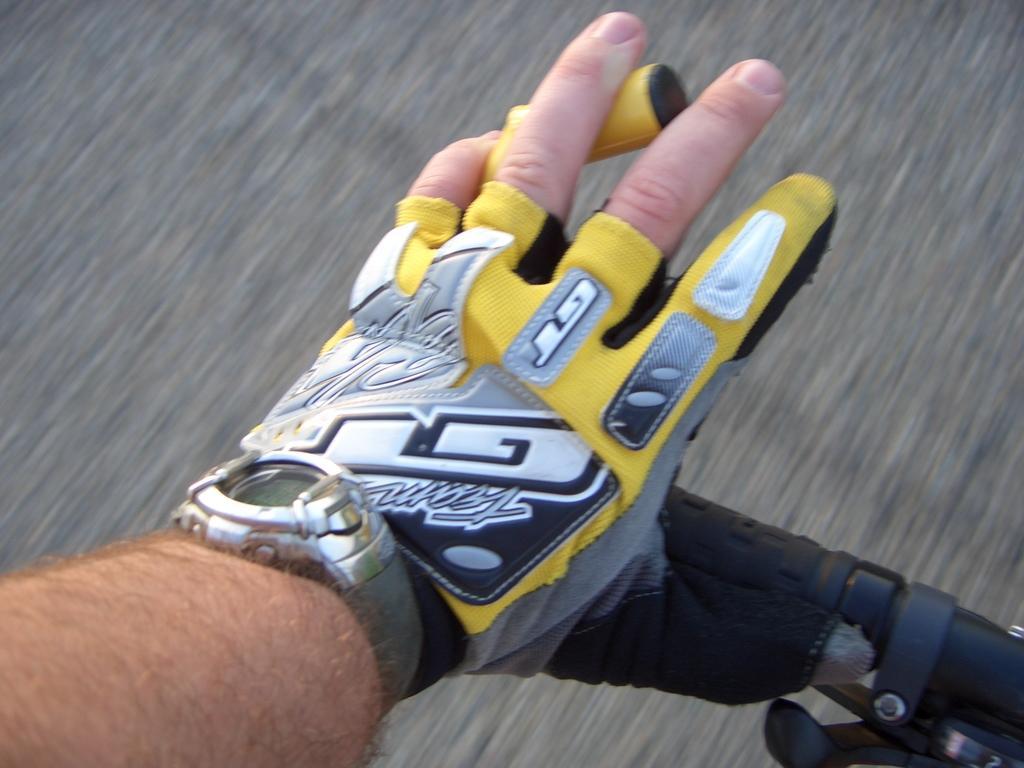Can you describe this image briefly? In this picture I can see a person's hand in front and this person is holding the handle and I see a watch on the hand and I see that the person is wearing a glove. 